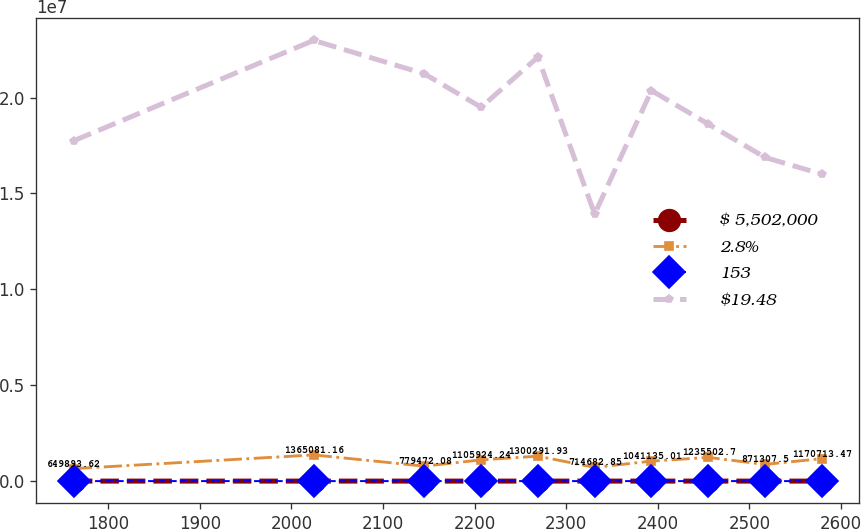Convert chart. <chart><loc_0><loc_0><loc_500><loc_500><line_chart><ecel><fcel>$ 5,502,000<fcel>2.8%<fcel>153<fcel>$19.48<nl><fcel>1762.5<fcel>201.27<fcel>649894<fcel>6.48<fcel>1.77526e+07<nl><fcel>2024.34<fcel>174.14<fcel>1.36508e+06<fcel>12.01<fcel>2.29823e+07<nl><fcel>2145.16<fcel>147<fcel>779472<fcel>10.12<fcel>2.12391e+07<nl><fcel>2207.13<fcel>133.43<fcel>1.10592e+06<fcel>9.49<fcel>1.94958e+07<nl><fcel>2269.1<fcel>160.57<fcel>1.30029e+06<fcel>11.38<fcel>2.21107e+07<nl><fcel>2331.07<fcel>79.15<fcel>714683<fcel>7.11<fcel>1.3929e+07<nl><fcel>2393.04<fcel>119.86<fcel>1.04114e+06<fcel>12.76<fcel>2.03675e+07<nl><fcel>2455.01<fcel>65.58<fcel>1.2355e+06<fcel>10.75<fcel>1.86242e+07<nl><fcel>2516.98<fcel>92.72<fcel>871308<fcel>8.86<fcel>1.6881e+07<nl><fcel>2578.95<fcel>106.29<fcel>1.17071e+06<fcel>8.23<fcel>1.60093e+07<nl></chart> 